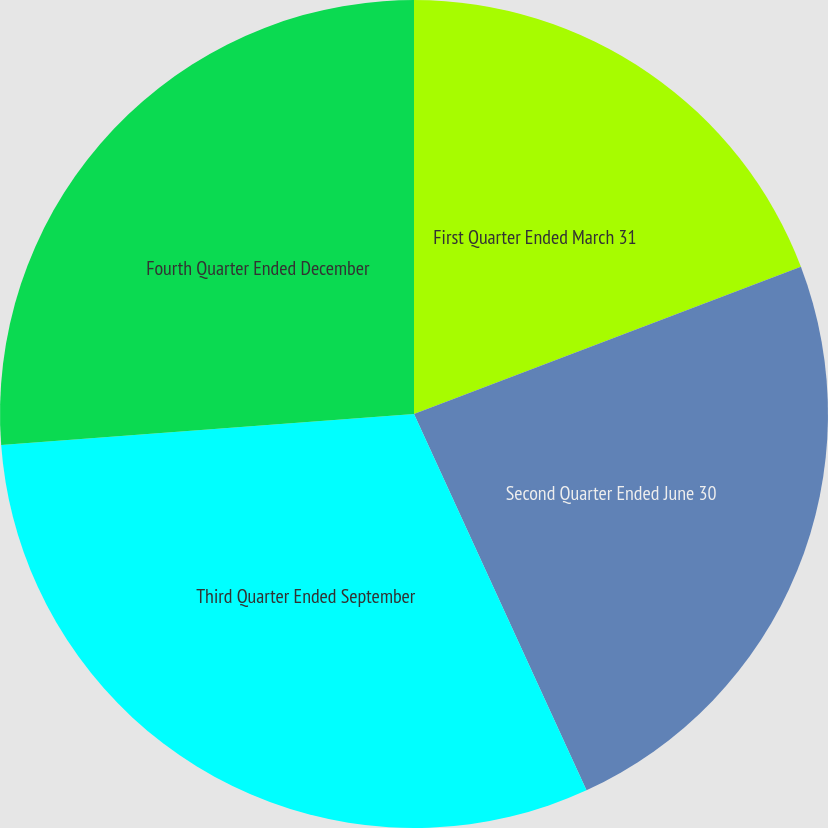Convert chart. <chart><loc_0><loc_0><loc_500><loc_500><pie_chart><fcel>First Quarter Ended March 31<fcel>Second Quarter Ended June 30<fcel>Third Quarter Ended September<fcel>Fourth Quarter Ended December<nl><fcel>19.21%<fcel>23.95%<fcel>30.65%<fcel>26.19%<nl></chart> 